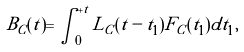Convert formula to latex. <formula><loc_0><loc_0><loc_500><loc_500>B _ { C } ( t ) = \int _ { 0 } ^ { + t } L _ { C } ( t - t _ { 1 } ) F _ { C } ( t _ { 1 } ) d t _ { 1 } ,</formula> 